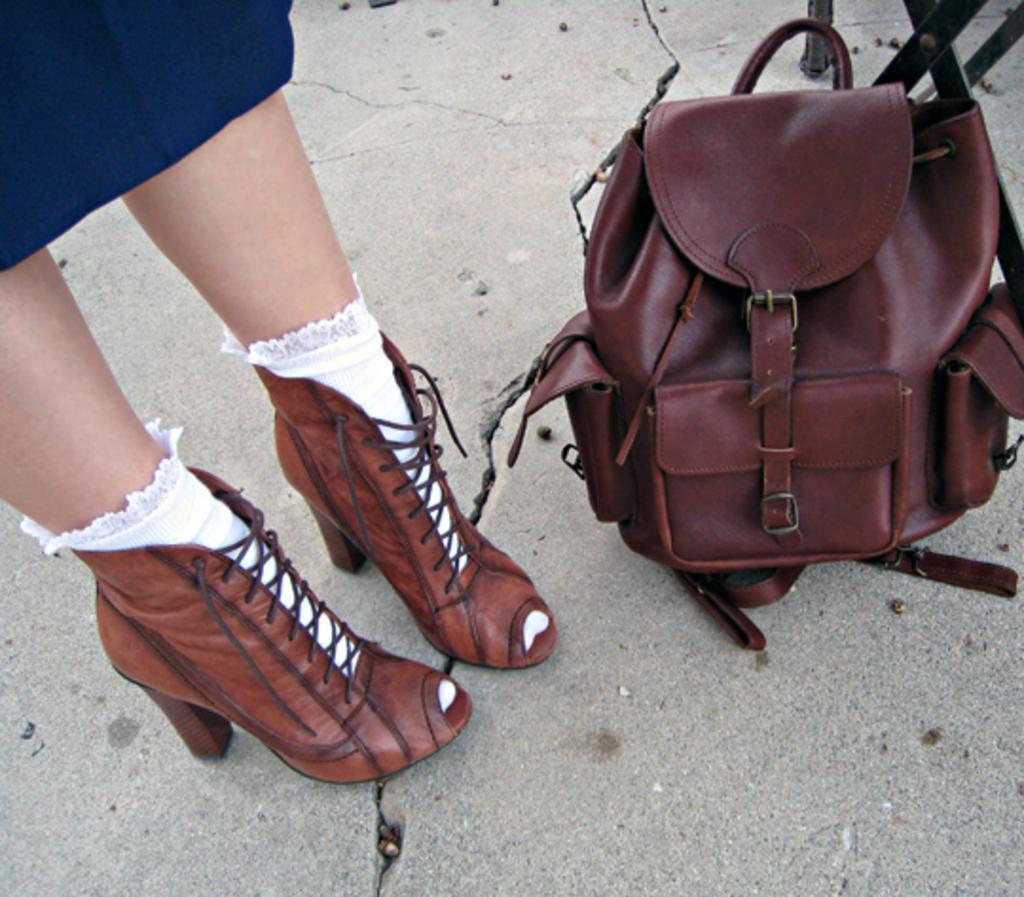Could you give a brief overview of what you see in this image? The women wearing a brown shoe and white socks is standing and there is a brown bag beside her. 